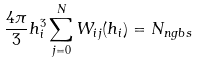<formula> <loc_0><loc_0><loc_500><loc_500>\frac { 4 \pi } { 3 } h ^ { 3 } _ { i } \sum _ { j = 0 } ^ { N } W _ { i j } ( h _ { i } ) = N _ { n g b s }</formula> 